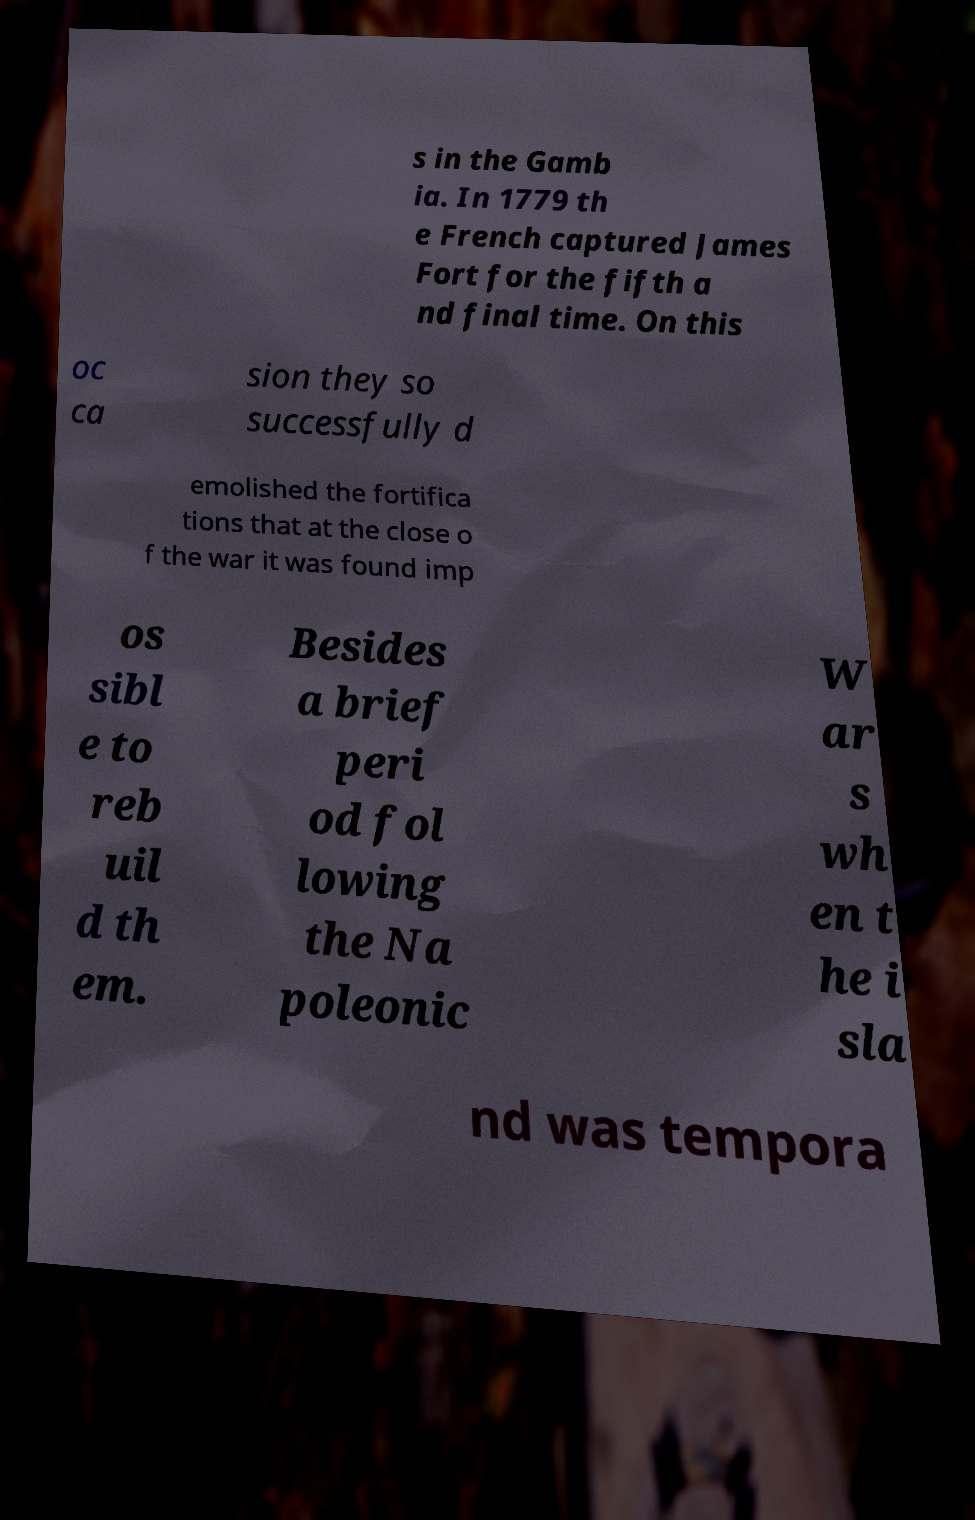There's text embedded in this image that I need extracted. Can you transcribe it verbatim? s in the Gamb ia. In 1779 th e French captured James Fort for the fifth a nd final time. On this oc ca sion they so successfully d emolished the fortifica tions that at the close o f the war it was found imp os sibl e to reb uil d th em. Besides a brief peri od fol lowing the Na poleonic W ar s wh en t he i sla nd was tempora 